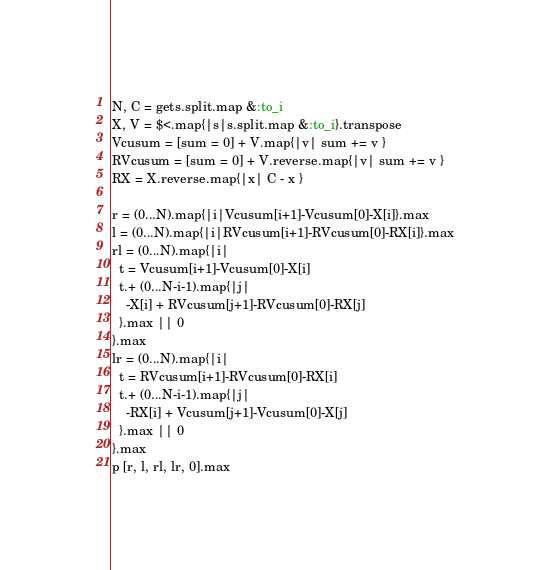Convert code to text. <code><loc_0><loc_0><loc_500><loc_500><_Ruby_>N, C = gets.split.map &:to_i
X, V = $<.map{|s|s.split.map &:to_i}.transpose
Vcusum = [sum = 0] + V.map{|v| sum += v }
RVcusum = [sum = 0] + V.reverse.map{|v| sum += v }
RX = X.reverse.map{|x| C - x }

r = (0...N).map{|i|Vcusum[i+1]-Vcusum[0]-X[i]}.max
l = (0...N).map{|i|RVcusum[i+1]-RVcusum[0]-RX[i]}.max
rl = (0...N).map{|i|
  t = Vcusum[i+1]-Vcusum[0]-X[i]
  t.+ (0...N-i-1).map{|j|
    -X[i] + RVcusum[j+1]-RVcusum[0]-RX[j]
  }.max || 0
}.max
lr = (0...N).map{|i|
  t = RVcusum[i+1]-RVcusum[0]-RX[i]
  t.+ (0...N-i-1).map{|j|
    -RX[i] + Vcusum[j+1]-Vcusum[0]-X[j]
  }.max || 0
}.max
p [r, l, rl, lr, 0].max
</code> 